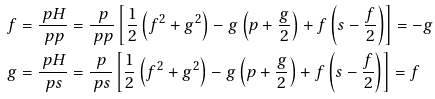<formula> <loc_0><loc_0><loc_500><loc_500>\ f & = \frac { \ p H } { \ p p } = \frac { \ p } { \ p p } \left [ \frac { 1 } { 2 } \left ( f ^ { 2 } + g ^ { 2 } \right ) - g \left ( p + \frac { g } { 2 } \right ) + f \left ( s - \frac { f } { 2 } \right ) \right ] = - g \\ \ g & = \frac { \ p H } { \ p s } = \frac { \ p } { \ p s } \left [ \frac { 1 } { 2 } \left ( f ^ { 2 } + g ^ { 2 } \right ) - g \left ( p + \frac { g } { 2 } \right ) + f \left ( s - \frac { f } { 2 } \right ) \right ] = f</formula> 